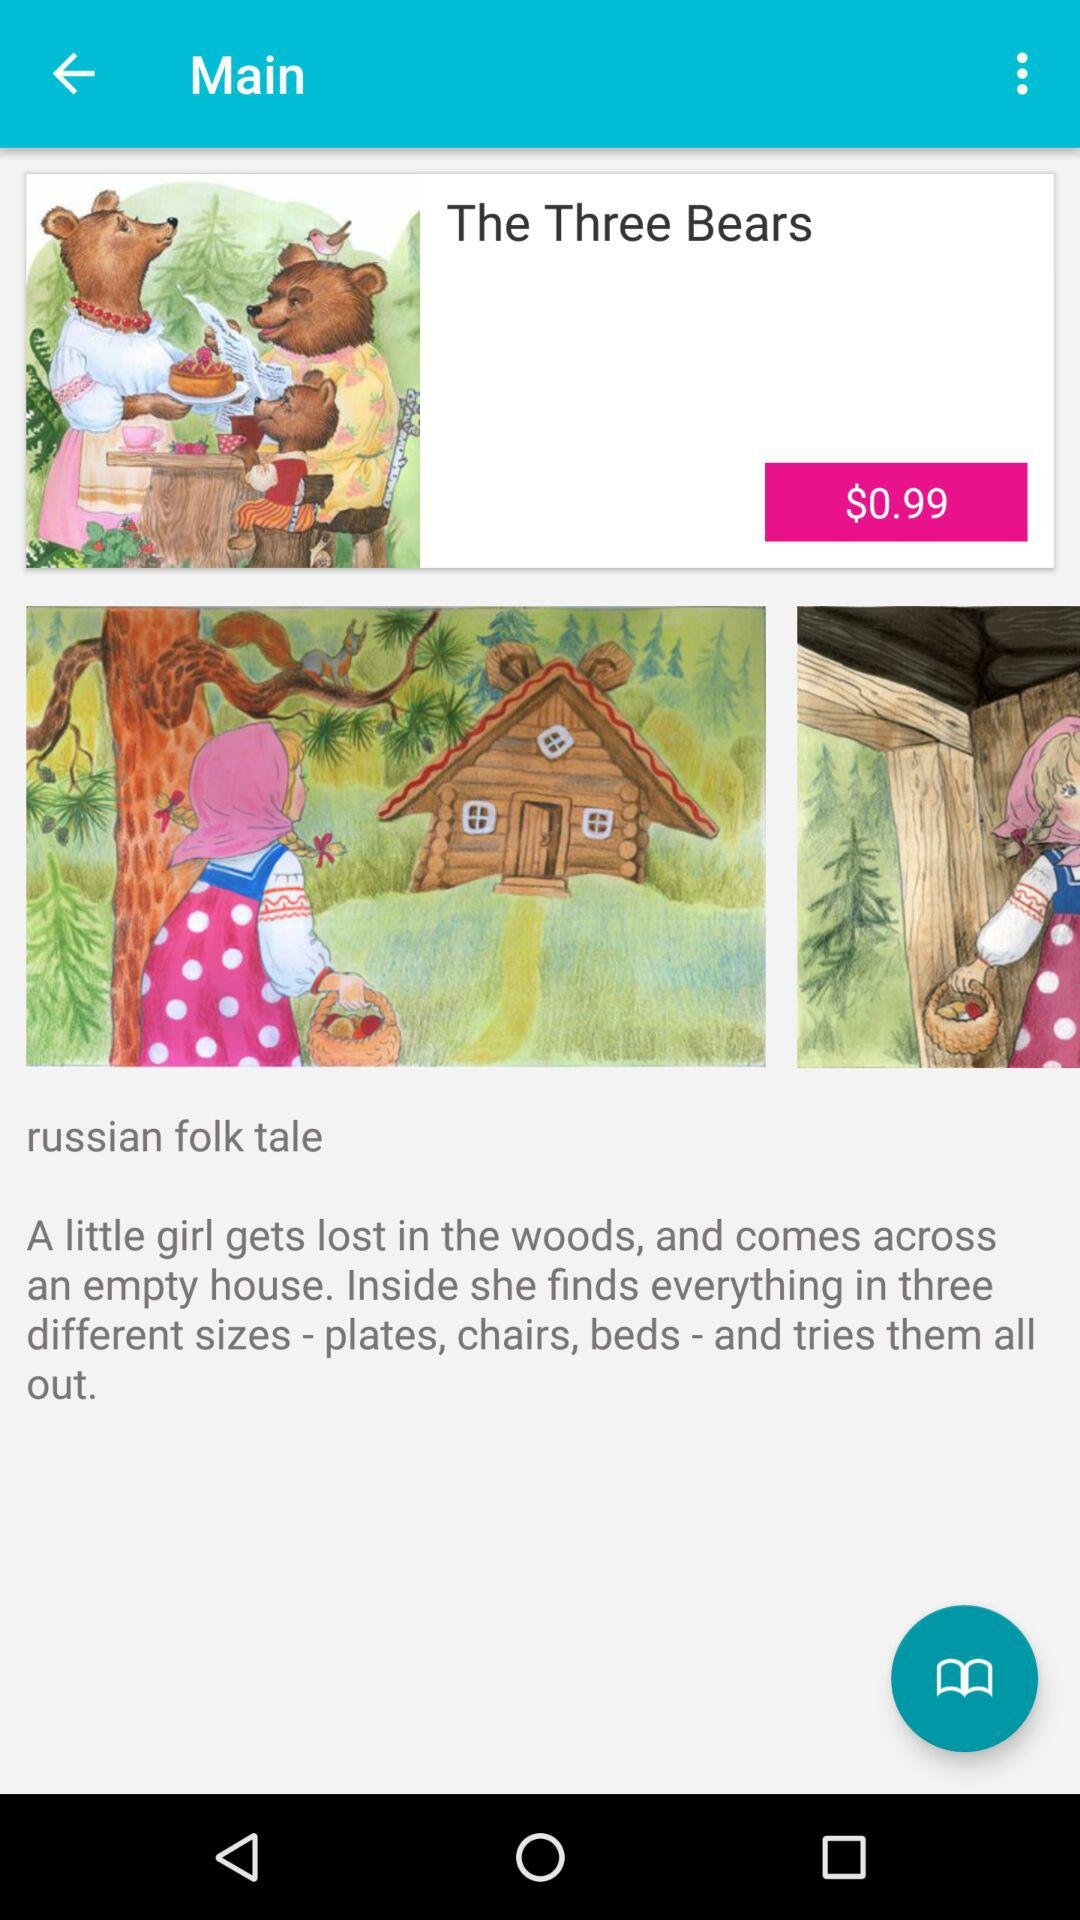What's the price of the " The Three Bears"? The price is $0.99. 